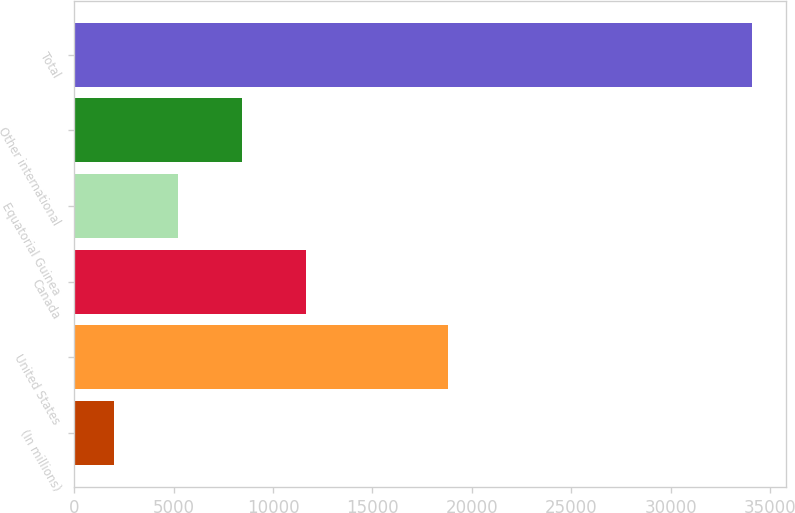Convert chart. <chart><loc_0><loc_0><loc_500><loc_500><bar_chart><fcel>(In millions)<fcel>United States<fcel>Canada<fcel>Equatorial Guinea<fcel>Other international<fcel>Total<nl><fcel>2009<fcel>18794<fcel>11639.6<fcel>5219.2<fcel>8429.4<fcel>34111<nl></chart> 